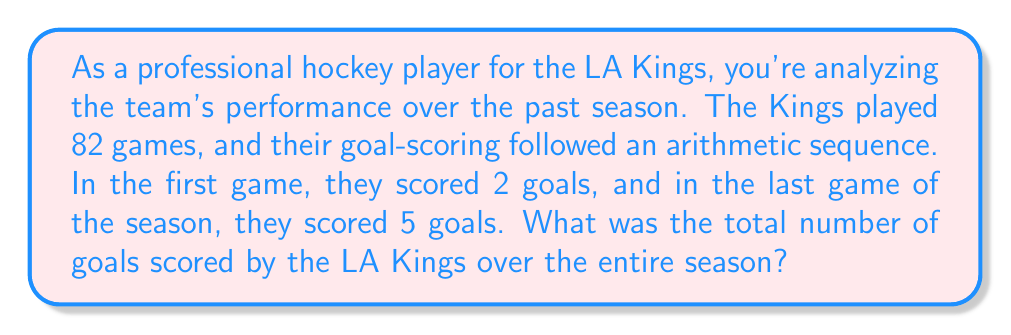Could you help me with this problem? Let's approach this step-by-step using the arithmetic sequence formula:

1) We know that:
   - Number of terms (n) = 82 (games in a season)
   - First term (a₁) = 2 (goals in the first game)
   - Last term (a₈₂) = 5 (goals in the last game)

2) For an arithmetic sequence, we can use the formula:
   $$ S_n = \frac{n}{2}(a_1 + a_n) $$
   Where $S_n$ is the sum of the sequence, and $n$ is the number of terms.

3) We have all the information to plug into this formula:
   $$ S_{82} = \frac{82}{2}(2 + 5) $$

4) Simplify:
   $$ S_{82} = 41(7) = 287 $$

5) Therefore, the total number of goals scored over the season is 287.

Note: This solution assumes that the goal-scoring strictly followed an arithmetic sequence. In reality, goal-scoring patterns would be more variable, but this model provides a useful approximation for analysis purposes.
Answer: 287 goals 